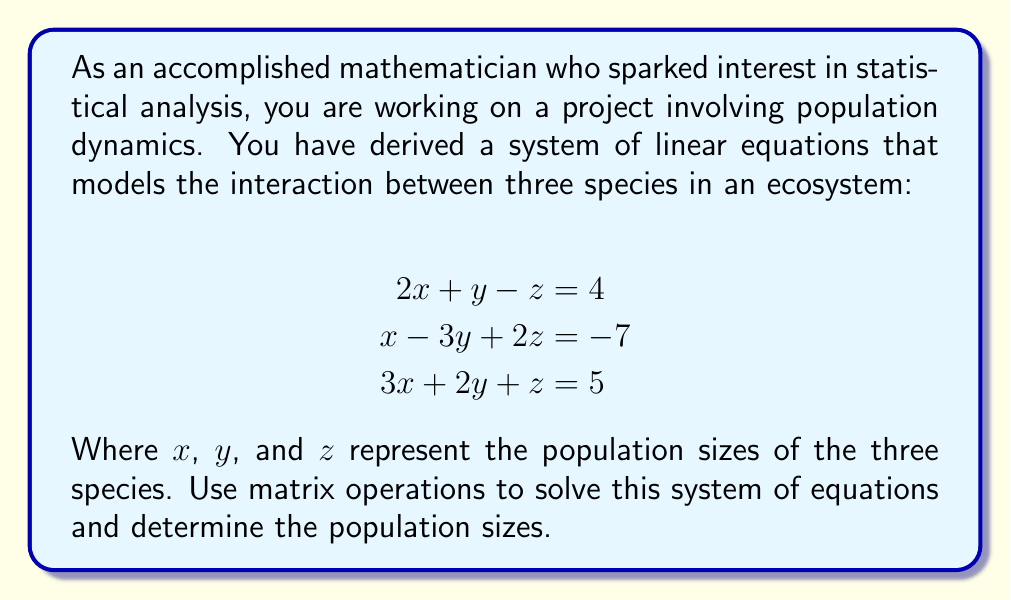Solve this math problem. To solve this system of linear equations using matrix operations, we'll follow these steps:

1. Express the system as an augmented matrix:

$$\begin{bmatrix}
2 & 1 & -1 & | & 4 \\
1 & -3 & 2 & | & -7 \\
3 & 2 & 1 & | & 5
\end{bmatrix}$$

2. Use Gaussian elimination to transform the matrix into row echelon form:

a) Multiply the first row by -1/2 and add it to the second row:
$$\begin{bmatrix}
2 & 1 & -1 & | & 4 \\
0 & -3.5 & 2.5 & | & -9 \\
3 & 2 & 1 & | & 5
\end{bmatrix}$$

b) Multiply the first row by -3/2 and add it to the third row:
$$\begin{bmatrix}
2 & 1 & -1 & | & 4 \\
0 & -3.5 & 2.5 & | & -9 \\
0 & 0.5 & 2.5 & | & -1
\end{bmatrix}$$

3. Transform the matrix into reduced row echelon form:

a) Multiply the second row by -2/7 to make the leading coefficient 1:
$$\begin{bmatrix}
2 & 1 & -1 & | & 4 \\
0 & 1 & -5/7 & | & 18/7 \\
0 & 0.5 & 2.5 & | & -1
\end{bmatrix}$$

b) Multiply the third row by 2 to eliminate the fraction:
$$\begin{bmatrix}
2 & 1 & -1 & | & 4 \\
0 & 1 & -5/7 & | & 18/7 \\
0 & 1 & 5 & | & -2
\end{bmatrix}$$

c) Subtract the second row from the third row:
$$\begin{bmatrix}
2 & 1 & -1 & | & 4 \\
0 & 1 & -5/7 & | & 18/7 \\
0 & 0 & 40/7 & | & -32/7
\end{bmatrix}$$

d) Multiply the third row by 7/40 to make the leading coefficient 1:
$$\begin{bmatrix}
2 & 1 & -1 & | & 4 \\
0 & 1 & -5/7 & | & 18/7 \\
0 & 0 & 1 & | & -4/5
\end{bmatrix}$$

4. Back-substitute to find the values of x, y, and z:

From the third row: $z = -4/5$

From the second row: $y - (5/7)(-4/5) = 18/7$
$y = 18/7 + (4/7) = 22/7$

From the first row: $2x + (22/7) - (-4/5) = 4$
$2x = 4 - (22/7) + (4/5) = 28/35 + 4/5 = 34/35$
$x = 17/35$

Therefore, the solution is:
$x = 17/35$, $y = 22/7$, and $z = -4/5$
Answer: The population sizes of the three species are:
$x = \frac{17}{35}$, $y = \frac{22}{7}$, and $z = -\frac{4}{5}$ 